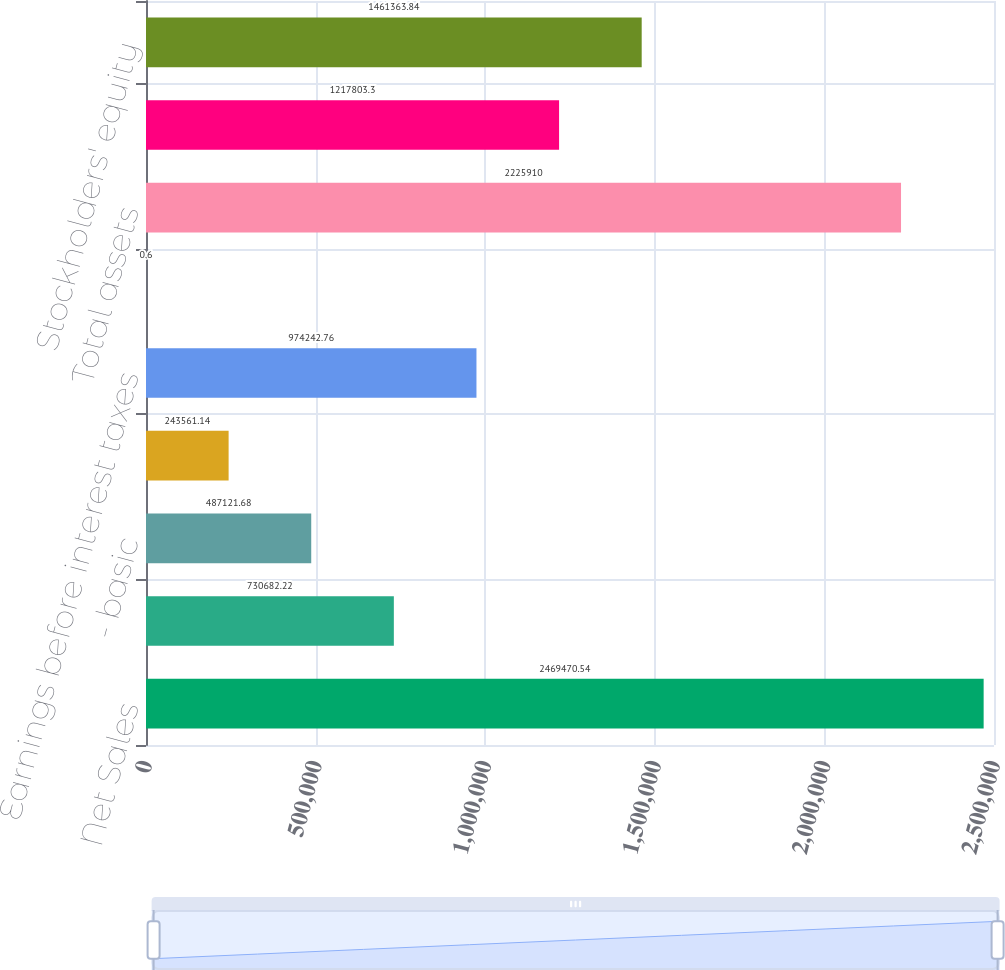Convert chart to OTSL. <chart><loc_0><loc_0><loc_500><loc_500><bar_chart><fcel>Net Sales<fcel>Net Income<fcel>- basic<fcel>- diluted<fcel>Earnings before interest taxes<fcel>Cash dividends declared per<fcel>Total assets<fcel>Total debt obligations<fcel>Stockholders' equity<nl><fcel>2.46947e+06<fcel>730682<fcel>487122<fcel>243561<fcel>974243<fcel>0.6<fcel>2.22591e+06<fcel>1.2178e+06<fcel>1.46136e+06<nl></chart> 